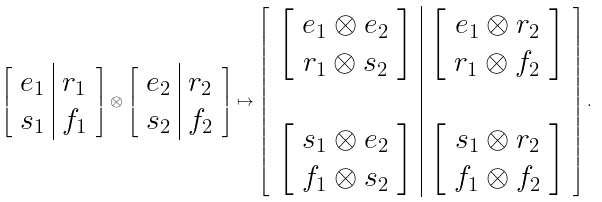Convert formula to latex. <formula><loc_0><loc_0><loc_500><loc_500>\left [ \begin{array} { c | c } e _ { 1 } & r _ { 1 } \\ s _ { 1 } & f _ { 1 } \end{array} \right ] \otimes \left [ \begin{array} { c | c } e _ { 2 } & r _ { 2 } \\ s _ { 2 } & f _ { 2 } \end{array} \right ] \mapsto \left [ \begin{array} { c | c } \left [ \begin{array} { c } e _ { 1 } \otimes e _ { 2 } \\ r _ { 1 } \otimes s _ { 2 } \end{array} \right ] & \left [ \begin{array} { c } e _ { 1 } \otimes r _ { 2 } \\ r _ { 1 } \otimes f _ { 2 } \end{array} \right ] \\ & \\ \left [ \begin{array} { c } s _ { 1 } \otimes e _ { 2 } \\ f _ { 1 } \otimes s _ { 2 } \end{array} \right ] & \left [ \begin{array} { c } s _ { 1 } \otimes r _ { 2 } \\ f _ { 1 } \otimes f _ { 2 } \end{array} \right ] \end{array} \right ] .</formula> 